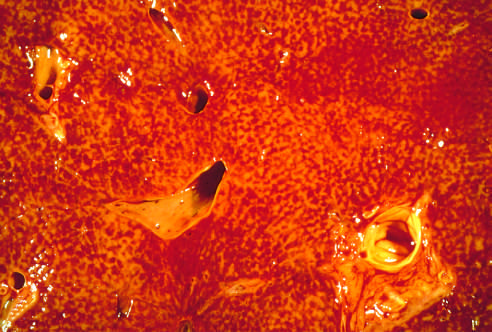what are visible?
Answer the question using a single word or phrase. Major blood vessels 